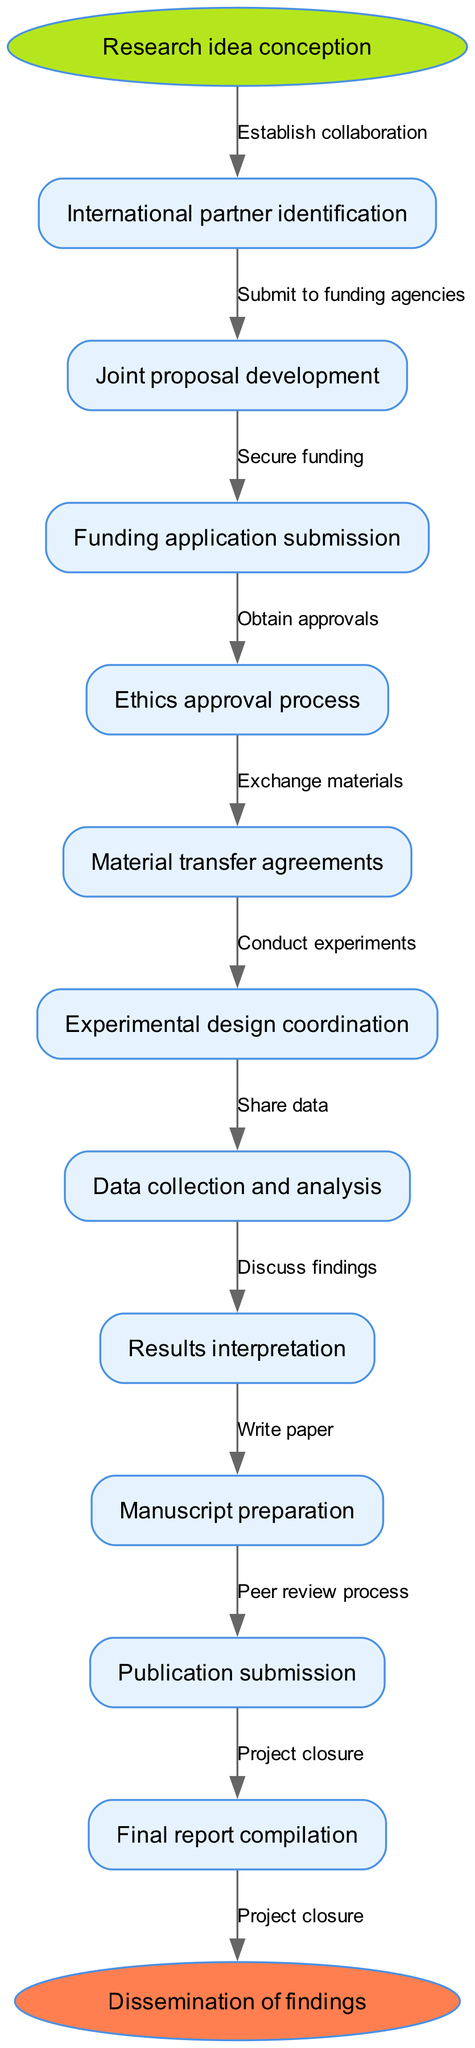What is the starting node of the diagram? The starting node is labeled as "Research idea conception," which signifies the initial stage of the collaborative cross-border molecular biology research project.
Answer: Research idea conception What is the last node before the final report compilation? The last node before the final report compilation is "Publication submission," indicating the step where the research findings are sent out for publication.
Answer: Publication submission How many nodes are in the diagram? By counting the nodes listed in the data, there are twelve nodes in the lifecycle of the research project, including the start and end nodes.
Answer: Twelve What is the edge connecting "Joint proposal development" to "Funding application submission"? The edge between these two nodes is labeled "Submit to funding agencies," which describes the process taken to move from joint proposal development to funding applications.
Answer: Submit to funding agencies What follows "Data collection and analysis" in the cycle? The process that follows is "Results interpretation," where the collected data is analyzed and discussed to derive conclusions.
Answer: Results interpretation What is the relationship between "Funding application submission" and "Secure funding"? The relationship is that these two nodes indicate a sequential process where after submitting a funding application, the next step is to secure the funding needed for the project.
Answer: Sequential process Name the stage related to legal agreements in the project lifecycle. The stage related to legal agreements is "Material transfer agreements," which must be established before sharing materials necessary for the project.
Answer: Material transfer agreements What is the final output of the workflow? The final output of the workflow is the "Dissemination of findings," which signifies the sharing and publication of the research outcomes with the public or scientific community.
Answer: Dissemination of findings In which node is the experimental work conducted? The experimental work is conducted in the node labeled "Experimental design coordination," where collaborative experiments are organized and executed across borders.
Answer: Experimental design coordination What is the purpose of obtaining ethics approval in the process? The purpose of obtaining ethics approval is to ensure that the research adheres to ethical standards and regulations, which is a crucial step before proceeding with experiments.
Answer: Ensure ethical standards 